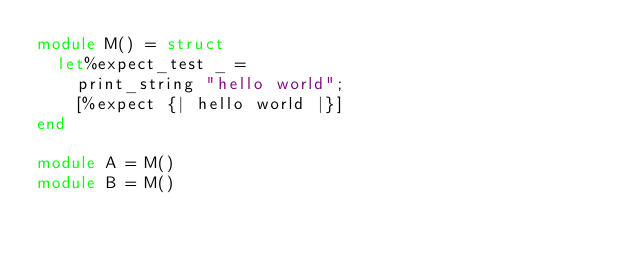Convert code to text. <code><loc_0><loc_0><loc_500><loc_500><_OCaml_>module M() = struct
  let%expect_test _ =
    print_string "hello world";
    [%expect {| hello world |}]
end

module A = M()
module B = M()
</code> 